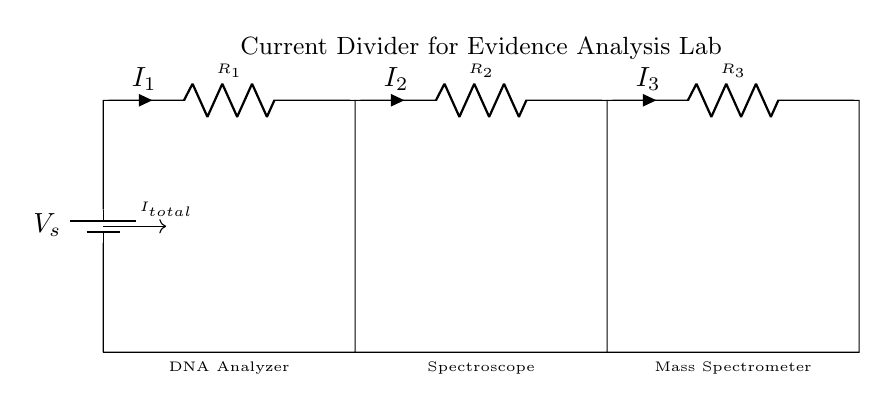What is the source voltage in this circuit? The source voltage, represented by the battery symbol \( V_s \), indicates the voltage supplied to the circuit. It is typically labeled, but the exact value is not given in the diagram.
Answer: V_s How many resistors are present in the current divider? The circuit shows three resistors labeled as \( R_1 \), \( R_2 \), and \( R_3 \). Each of these resistors is connected in parallel, forming the current divider.
Answer: 3 What is the total current entering the current divider? The total current entering the circuit is represented as \( I_{total} \). It is the sum of the currents through each resistor, \( I_1 \), \( I_2 \), and \( I_3 \), which are dictated by the resistances.
Answer: I_total Which components are powered by this current divider? The circuit diagram indicates three components powered by the current divider: a DNA Analyzer, a Spectroscope, and a Mass Spectrometer, each located at the bottom of the diagram.
Answer: DNA Analyzer, Spectroscope, Mass Spectrometer What type of arrangement do the resistors form in this circuit? The resistors \( R_1 \), \( R_2 \), and \( R_3 \) are connected in parallel, which means the current divides among these resistors based on their resistance values.
Answer: Parallel How does the current split among the resistors? The current splits among the resistors based on the resistance values, following the formula \( I_n = \frac{V}{R_n} \). This means lower resistance will receive a higher proportion of the total current.
Answer: According to resistance values What is the purpose of the current divider circuit in the lab? The purpose of this current divider is to supply different amounts of current to the various sensors used in the evidence analysis lab, ensuring that each sensor operates effectively.
Answer: Powering sensors 